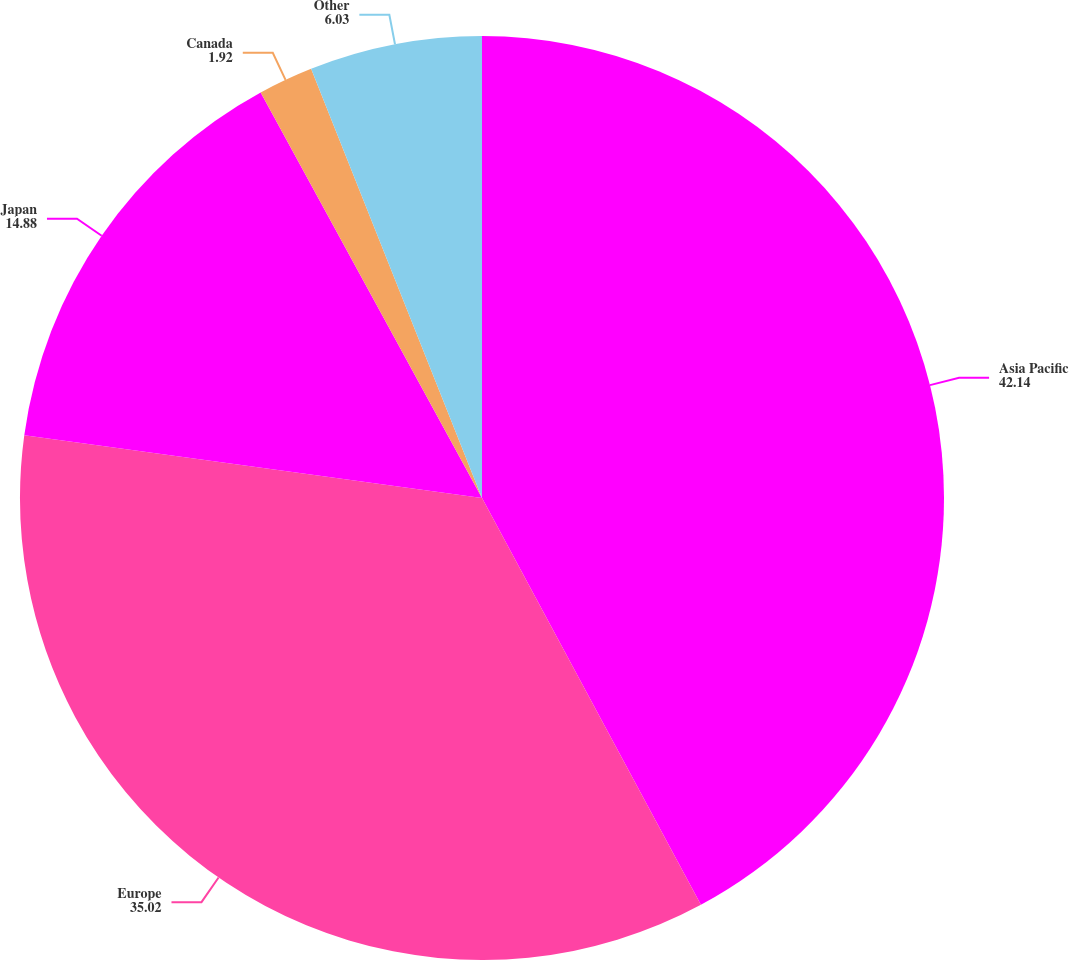Convert chart to OTSL. <chart><loc_0><loc_0><loc_500><loc_500><pie_chart><fcel>Asia Pacific<fcel>Europe<fcel>Japan<fcel>Canada<fcel>Other<nl><fcel>42.14%<fcel>35.02%<fcel>14.88%<fcel>1.92%<fcel>6.03%<nl></chart> 